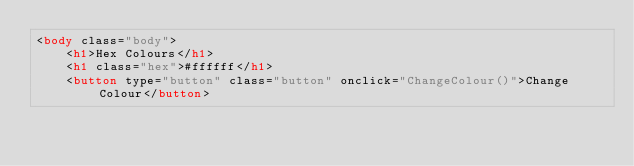Convert code to text. <code><loc_0><loc_0><loc_500><loc_500><_HTML_><body class="body">
    <h1>Hex Colours</h1>
    <h1 class="hex">#ffffff</h1>
    <button type="button" class="button" onclick="ChangeColour()">Change Colour</button></code> 